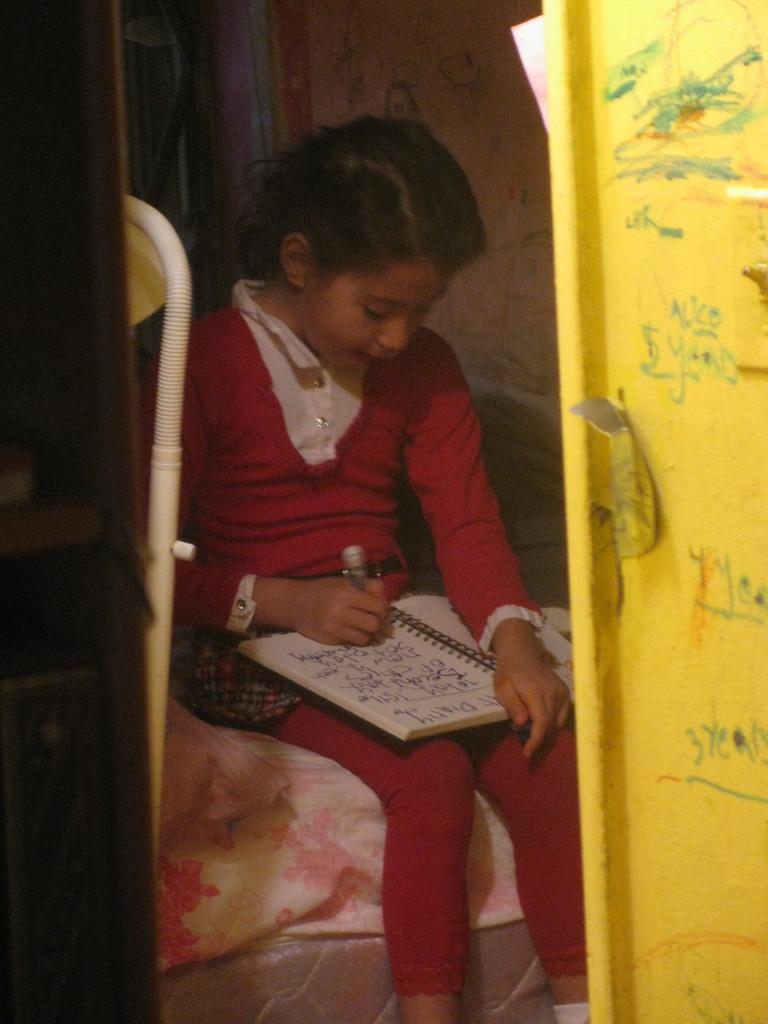How would you summarize this image in a sentence or two? In this image there is a girl sitting, she is holding an object, there is a book, there is text on the book, there is an object towards the right of the image, there is text on the object, there is an object towards the left of the image, there is a wall towards the top of the image, there is text on the wall, there is an object towards the top of the image, there is a blanket, at the bottom of the image there is a mattress. 